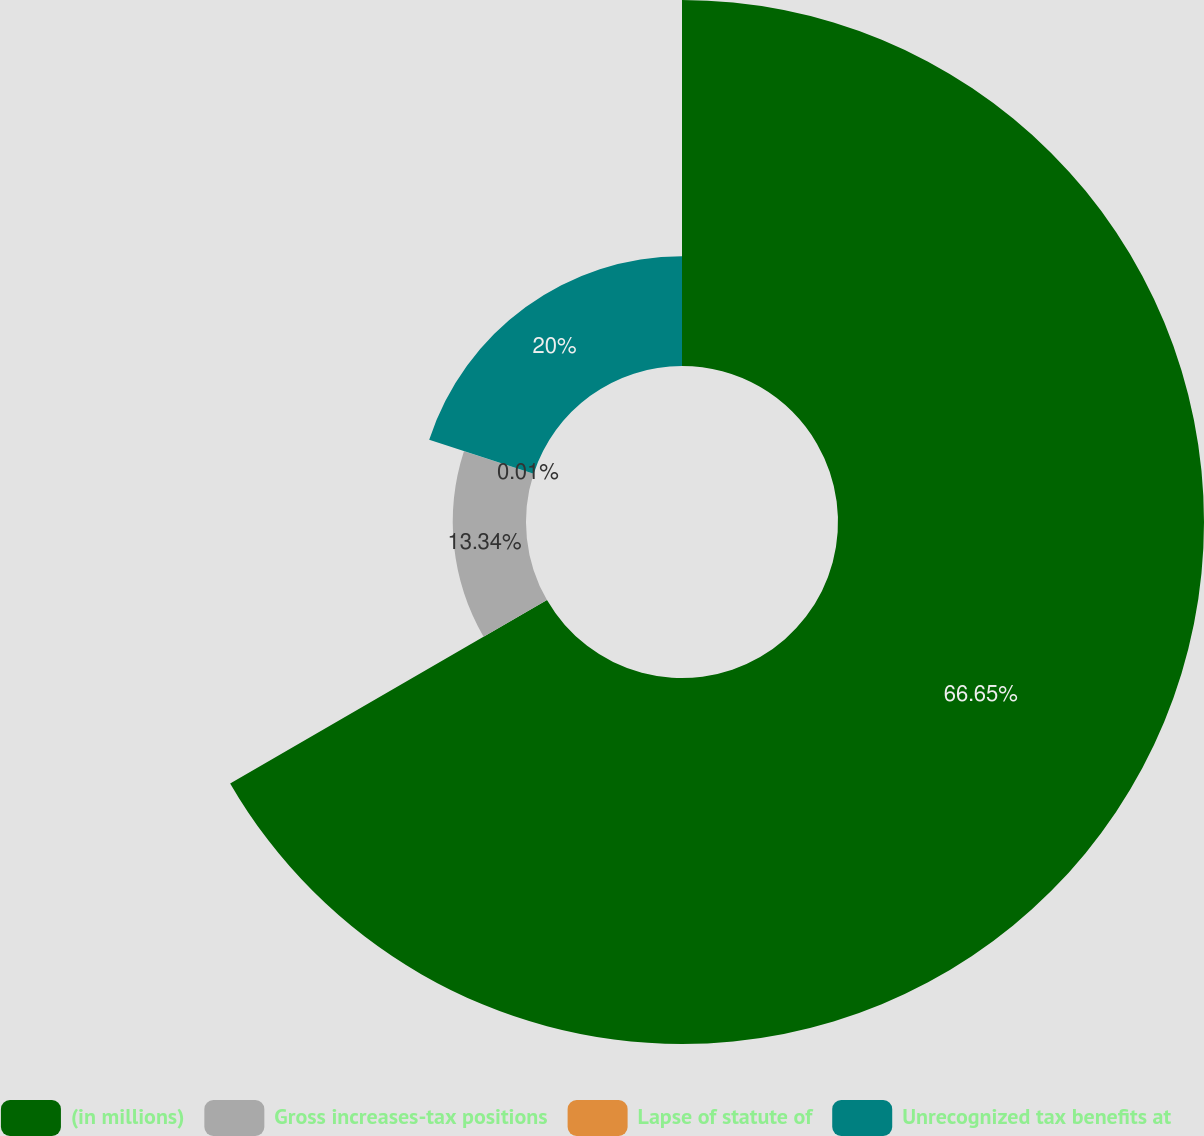<chart> <loc_0><loc_0><loc_500><loc_500><pie_chart><fcel>(in millions)<fcel>Gross increases-tax positions<fcel>Lapse of statute of<fcel>Unrecognized tax benefits at<nl><fcel>66.66%<fcel>13.34%<fcel>0.01%<fcel>20.0%<nl></chart> 